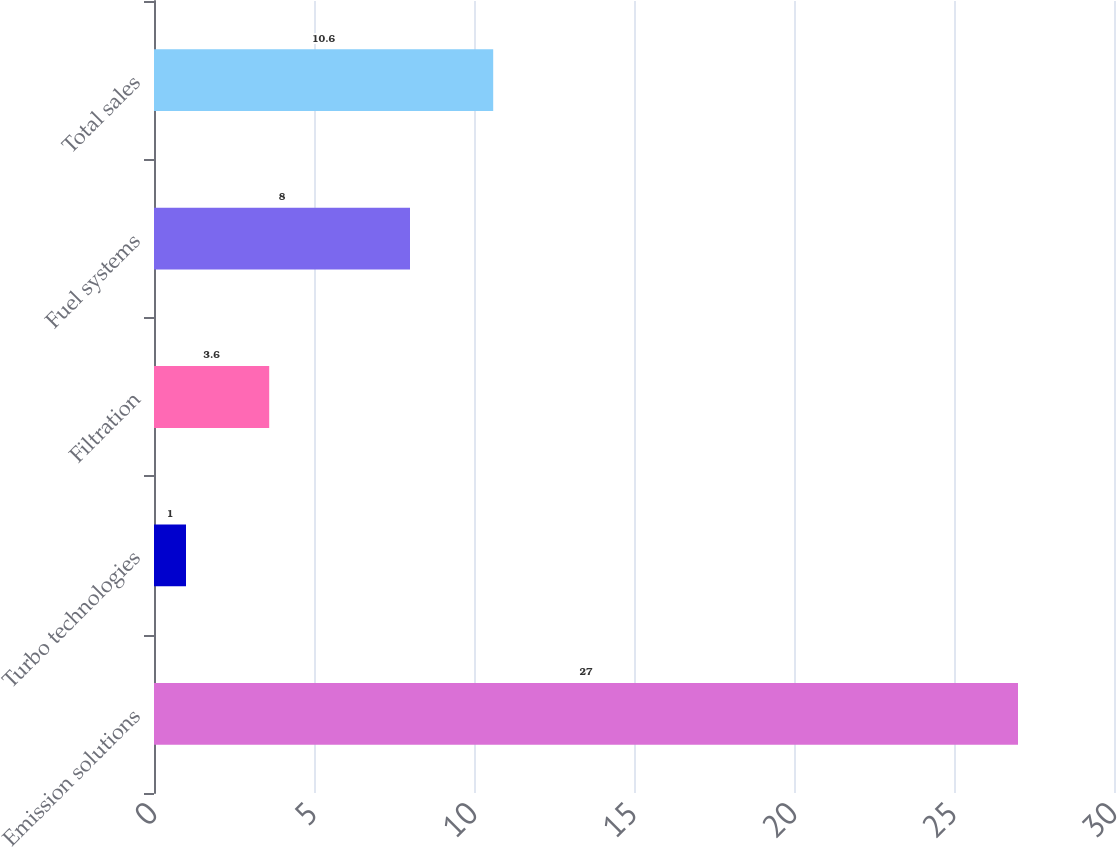<chart> <loc_0><loc_0><loc_500><loc_500><bar_chart><fcel>Emission solutions<fcel>Turbo technologies<fcel>Filtration<fcel>Fuel systems<fcel>Total sales<nl><fcel>27<fcel>1<fcel>3.6<fcel>8<fcel>10.6<nl></chart> 